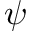<formula> <loc_0><loc_0><loc_500><loc_500>\psi</formula> 